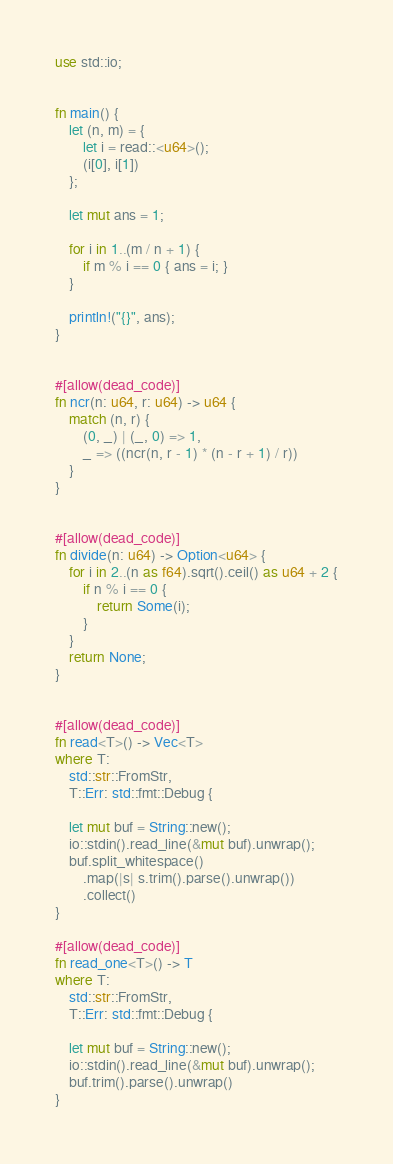<code> <loc_0><loc_0><loc_500><loc_500><_Rust_>use std::io;


fn main() {
    let (n, m) = {
        let i = read::<u64>();
        (i[0], i[1])
    };

    let mut ans = 1;

    for i in 1..(m / n + 1) {
        if m % i == 0 { ans = i; }
    }

    println!("{}", ans);
}


#[allow(dead_code)]
fn ncr(n: u64, r: u64) -> u64 {
    match (n, r) {
        (0, _) | (_, 0) => 1,
        _ => ((ncr(n, r - 1) * (n - r + 1) / r))
    }
}


#[allow(dead_code)]
fn divide(n: u64) -> Option<u64> {
    for i in 2..(n as f64).sqrt().ceil() as u64 + 2 {
        if n % i == 0 {
            return Some(i);
        }
    } 
    return None;
}


#[allow(dead_code)]
fn read<T>() -> Vec<T>
where T:
    std::str::FromStr,
    T::Err: std::fmt::Debug {

    let mut buf = String::new();
    io::stdin().read_line(&mut buf).unwrap();
    buf.split_whitespace()
        .map(|s| s.trim().parse().unwrap())
        .collect()
}

#[allow(dead_code)]
fn read_one<T>() -> T
where T:
    std::str::FromStr,
    T::Err: std::fmt::Debug {

    let mut buf = String::new();
    io::stdin().read_line(&mut buf).unwrap();
    buf.trim().parse().unwrap()
}</code> 